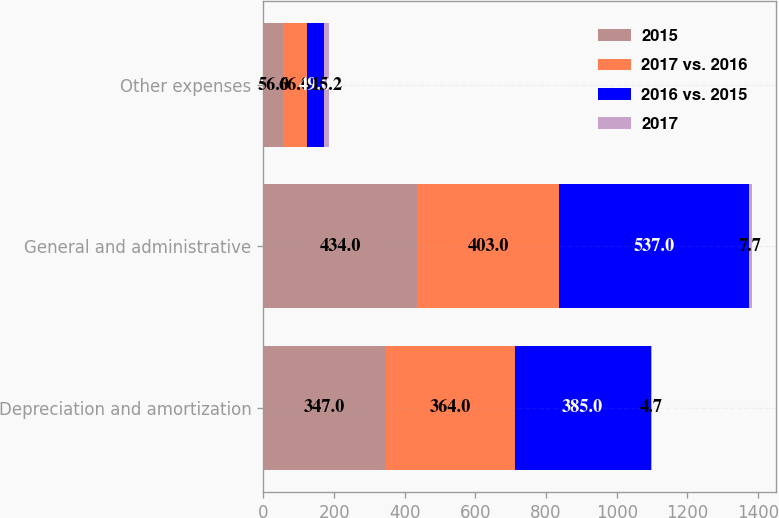<chart> <loc_0><loc_0><loc_500><loc_500><stacked_bar_chart><ecel><fcel>Depreciation and amortization<fcel>General and administrative<fcel>Other expenses<nl><fcel>2015<fcel>347<fcel>434<fcel>56<nl><fcel>2017 vs. 2016<fcel>364<fcel>403<fcel>66<nl><fcel>2016 vs. 2015<fcel>385<fcel>537<fcel>49<nl><fcel>2017<fcel>4.7<fcel>7.7<fcel>15.2<nl></chart> 